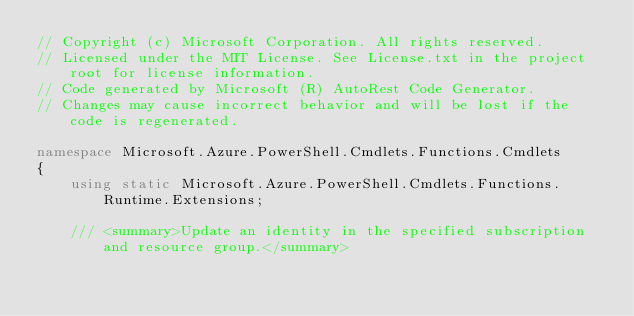Convert code to text. <code><loc_0><loc_0><loc_500><loc_500><_C#_>// Copyright (c) Microsoft Corporation. All rights reserved.
// Licensed under the MIT License. See License.txt in the project root for license information.
// Code generated by Microsoft (R) AutoRest Code Generator.
// Changes may cause incorrect behavior and will be lost if the code is regenerated.

namespace Microsoft.Azure.PowerShell.Cmdlets.Functions.Cmdlets
{
    using static Microsoft.Azure.PowerShell.Cmdlets.Functions.Runtime.Extensions;

    /// <summary>Update an identity in the specified subscription and resource group.</summary></code> 